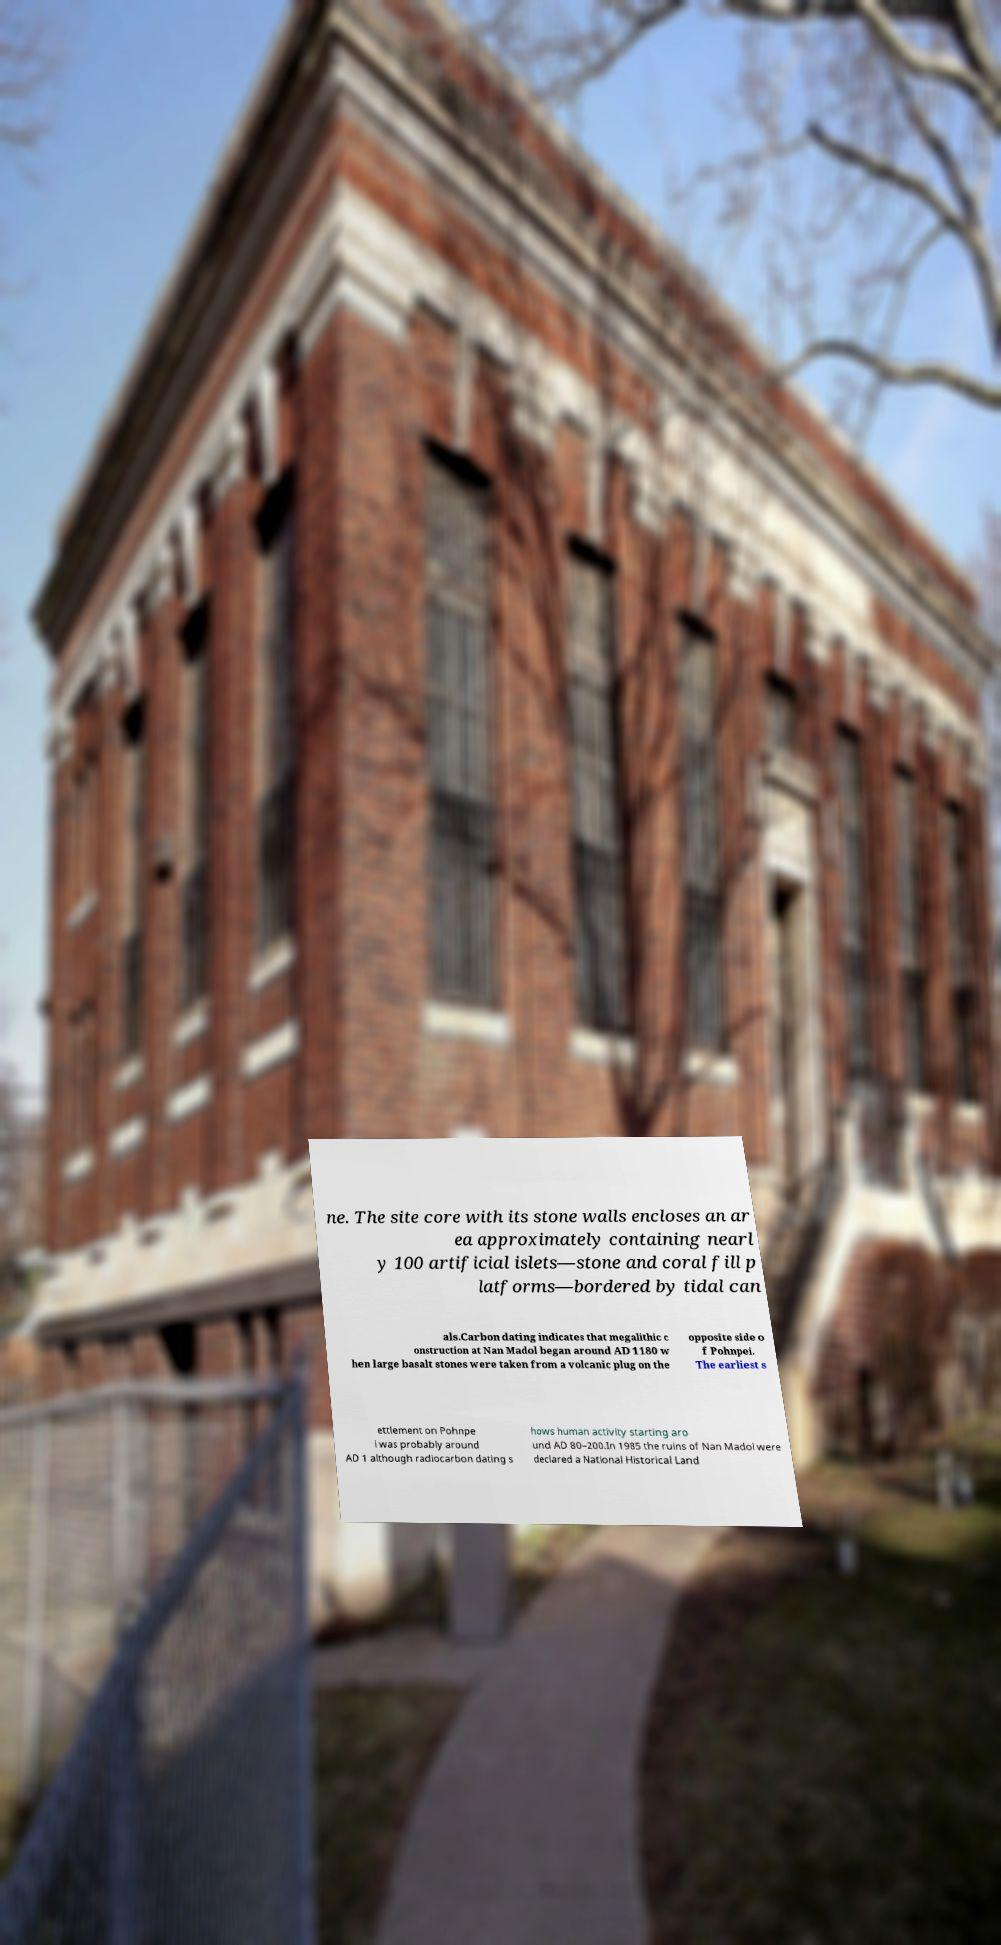I need the written content from this picture converted into text. Can you do that? ne. The site core with its stone walls encloses an ar ea approximately containing nearl y 100 artificial islets—stone and coral fill p latforms—bordered by tidal can als.Carbon dating indicates that megalithic c onstruction at Nan Madol began around AD 1180 w hen large basalt stones were taken from a volcanic plug on the opposite side o f Pohnpei. The earliest s ettlement on Pohnpe i was probably around AD 1 although radiocarbon dating s hows human activity starting aro und AD 80–200.In 1985 the ruins of Nan Madol were declared a National Historical Land 